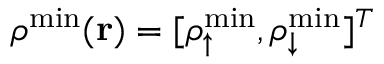<formula> <loc_0><loc_0><loc_500><loc_500>{ \boldsymbol \rho } ^ { \min } ( { r } ) = [ \rho _ { \uparrow } ^ { \min } , \rho _ { \downarrow } ^ { \min } ] ^ { T }</formula> 